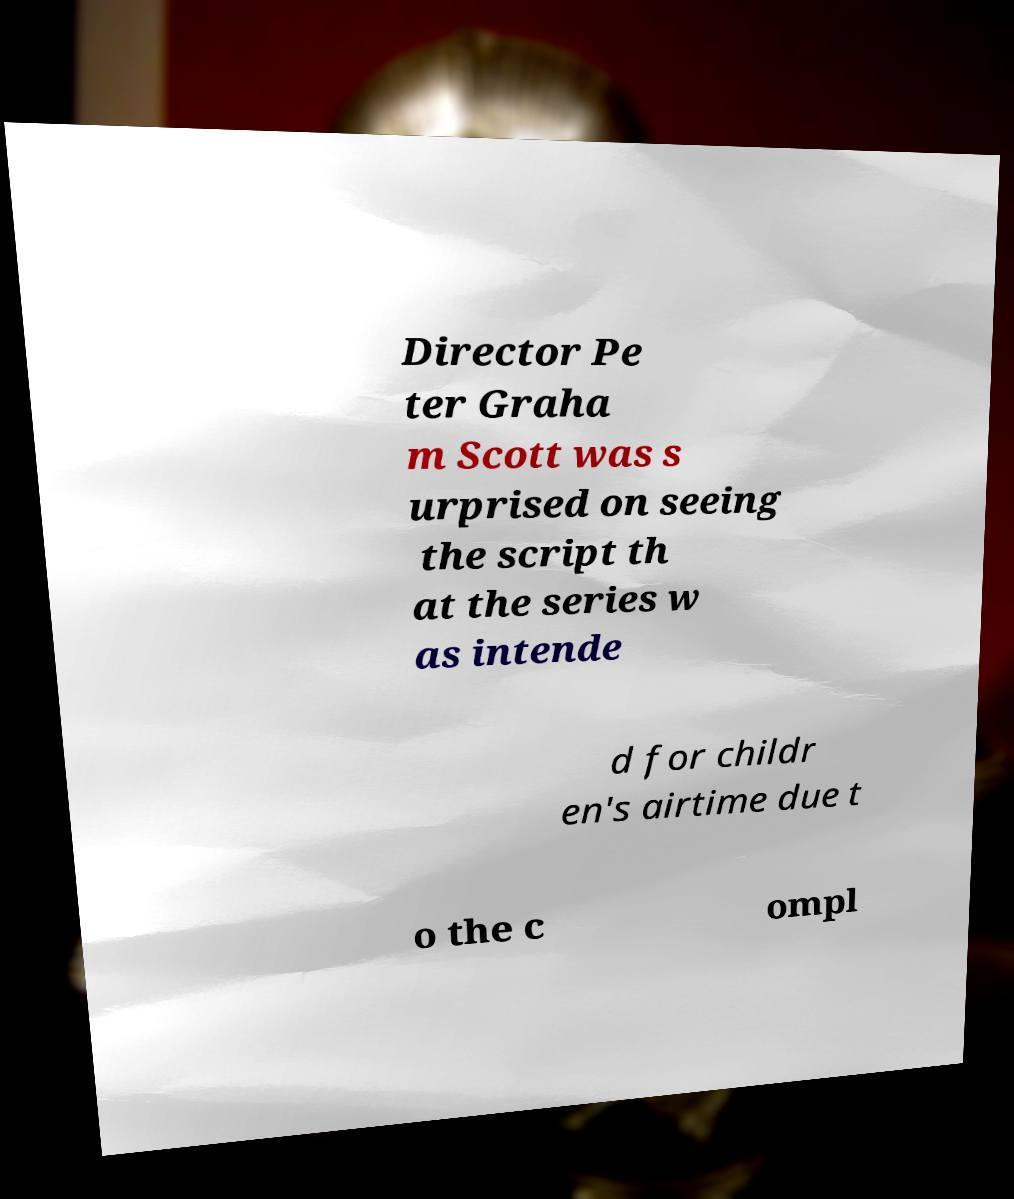Please read and relay the text visible in this image. What does it say? Director Pe ter Graha m Scott was s urprised on seeing the script th at the series w as intende d for childr en's airtime due t o the c ompl 